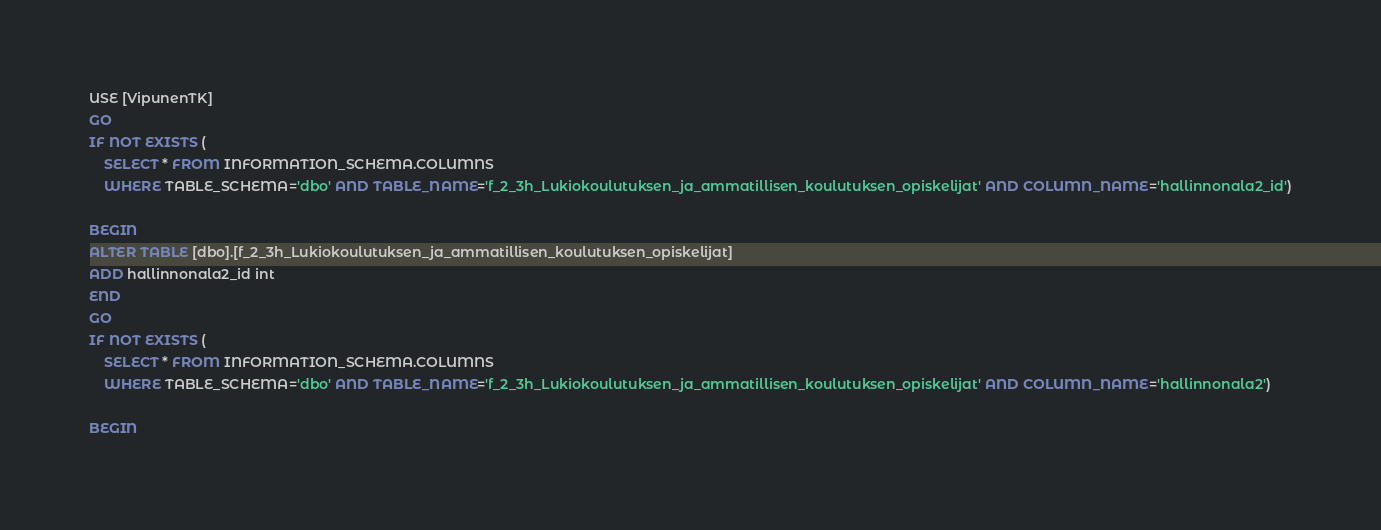<code> <loc_0><loc_0><loc_500><loc_500><_SQL_>USE [VipunenTK]
GO
IF NOT EXISTS (
	SELECT * FROM INFORMATION_SCHEMA.COLUMNS
	WHERE TABLE_SCHEMA='dbo' AND TABLE_NAME='f_2_3h_Lukiokoulutuksen_ja_ammatillisen_koulutuksen_opiskelijat' AND COLUMN_NAME='hallinnonala2_id')

BEGIN
ALTER TABLE [dbo].[f_2_3h_Lukiokoulutuksen_ja_ammatillisen_koulutuksen_opiskelijat]
ADD hallinnonala2_id int
END
GO
IF NOT EXISTS (
	SELECT * FROM INFORMATION_SCHEMA.COLUMNS
	WHERE TABLE_SCHEMA='dbo' AND TABLE_NAME='f_2_3h_Lukiokoulutuksen_ja_ammatillisen_koulutuksen_opiskelijat' AND COLUMN_NAME='hallinnonala2')

BEGIN</code> 